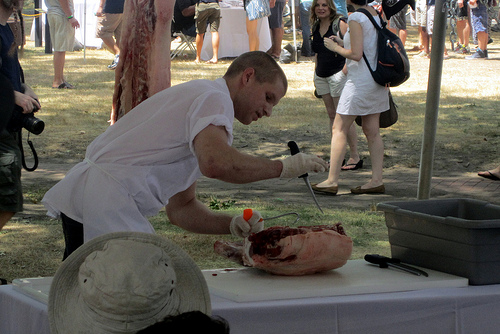<image>
Can you confirm if the hat is on the table? No. The hat is not positioned on the table. They may be near each other, but the hat is not supported by or resting on top of the table. Is the shoe behind the meat? No. The shoe is not behind the meat. From this viewpoint, the shoe appears to be positioned elsewhere in the scene. 